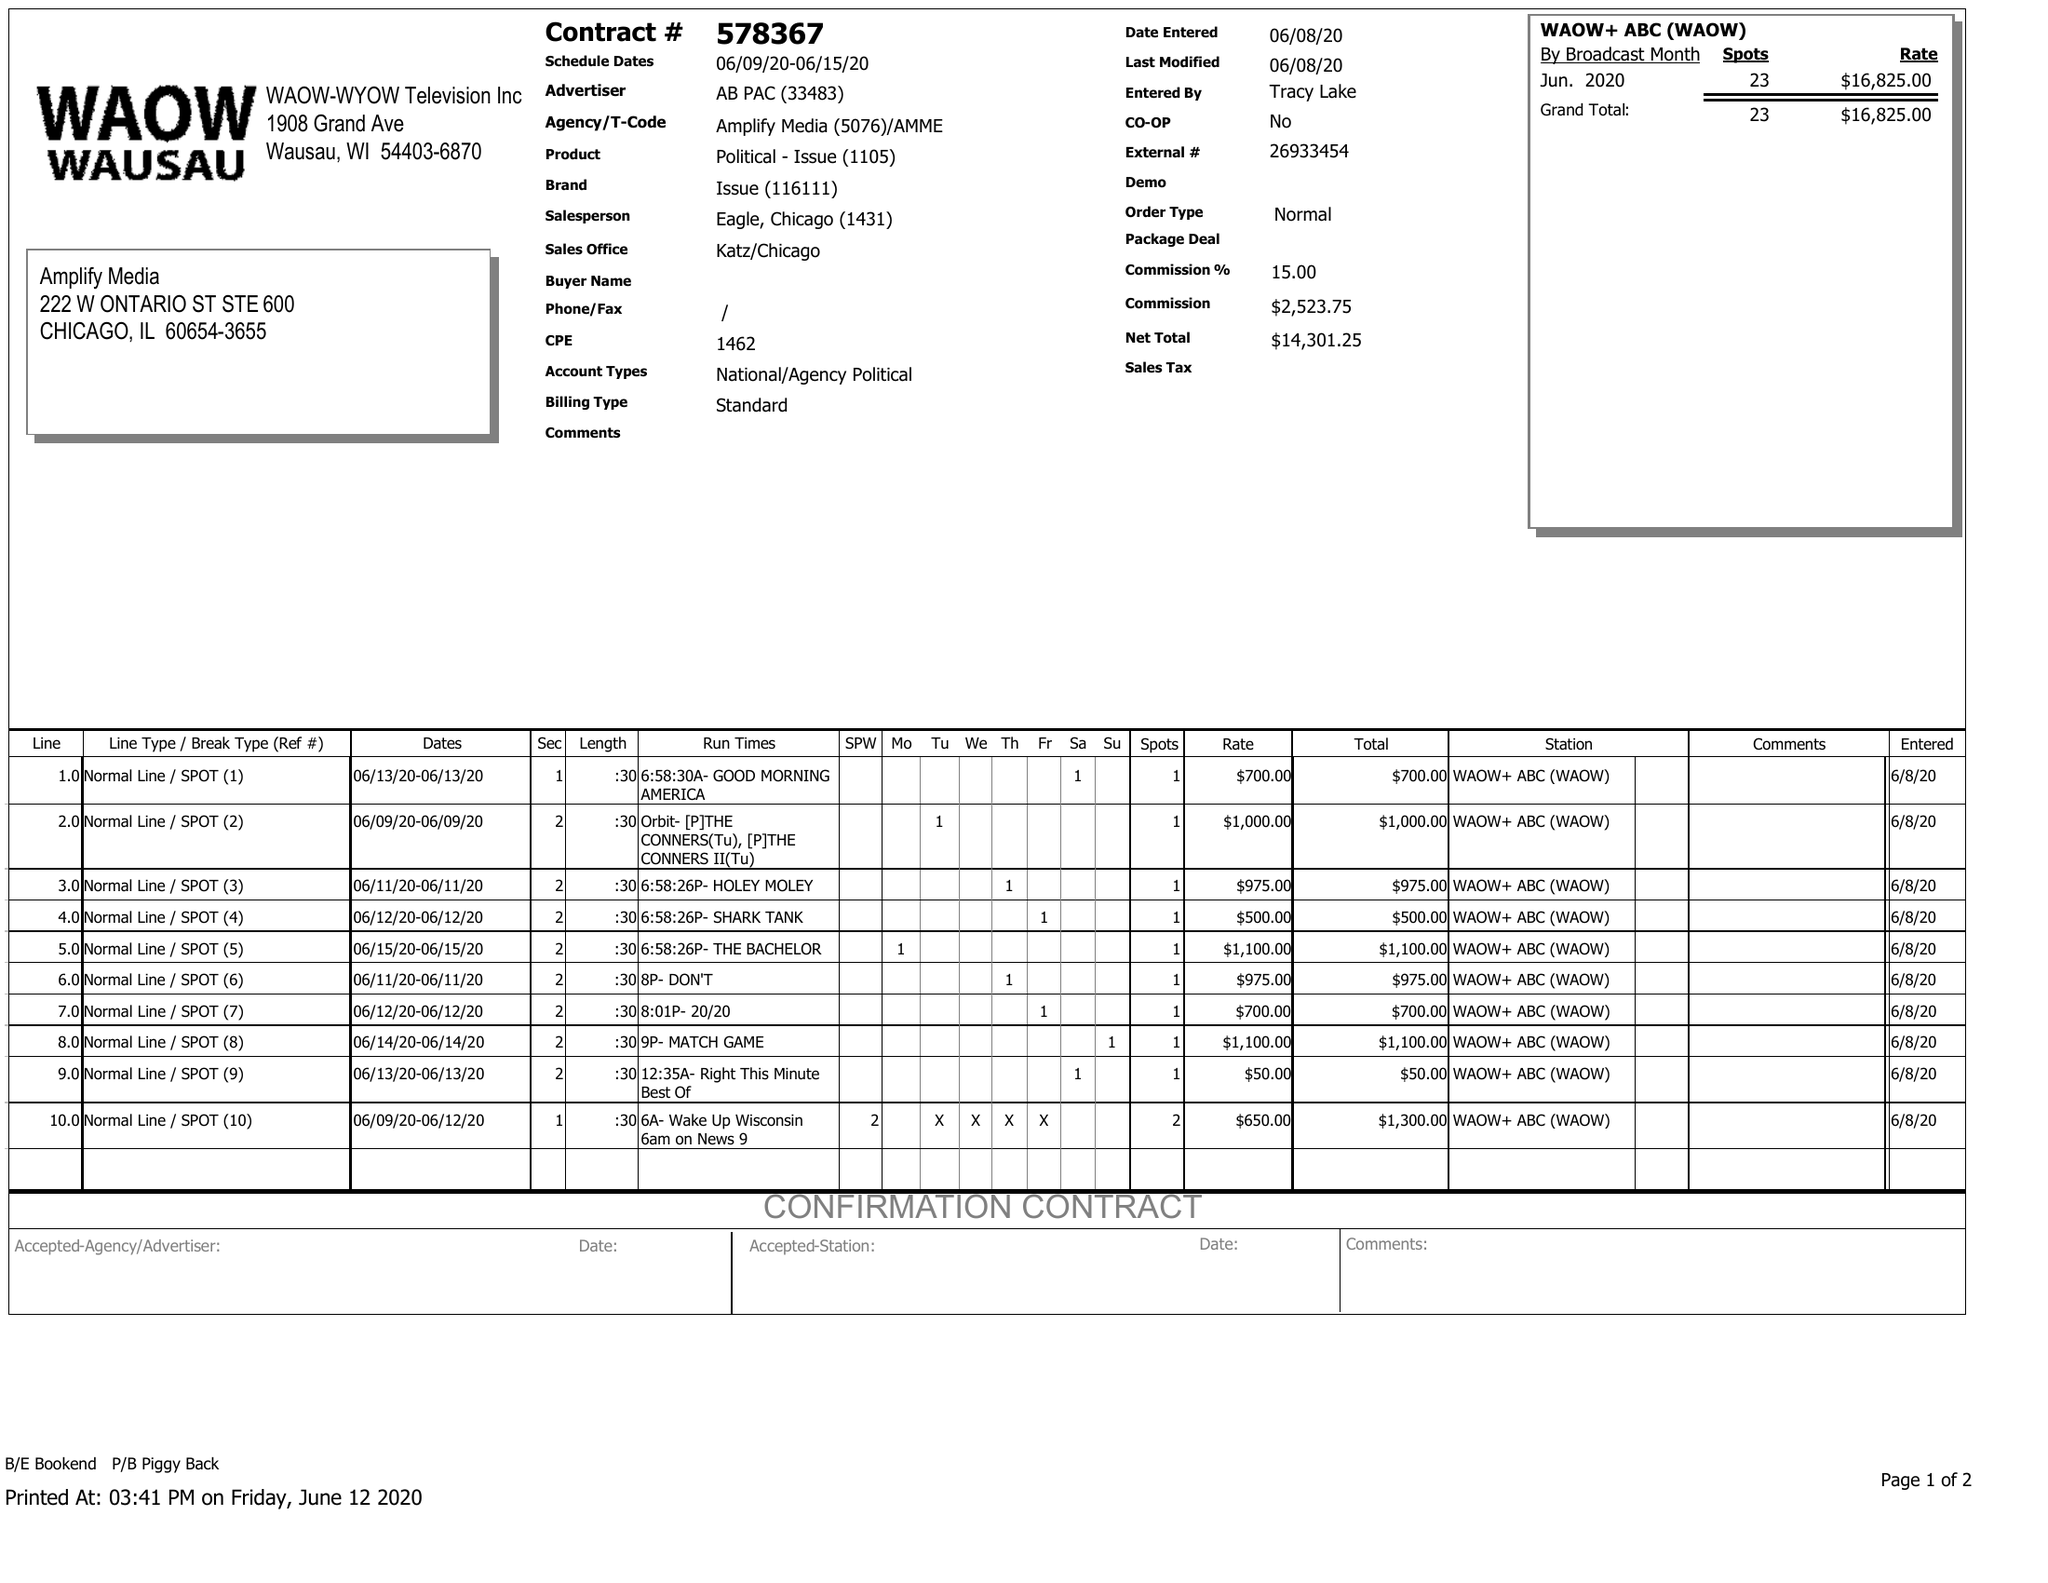What is the value for the advertiser?
Answer the question using a single word or phrase. AB PAC 